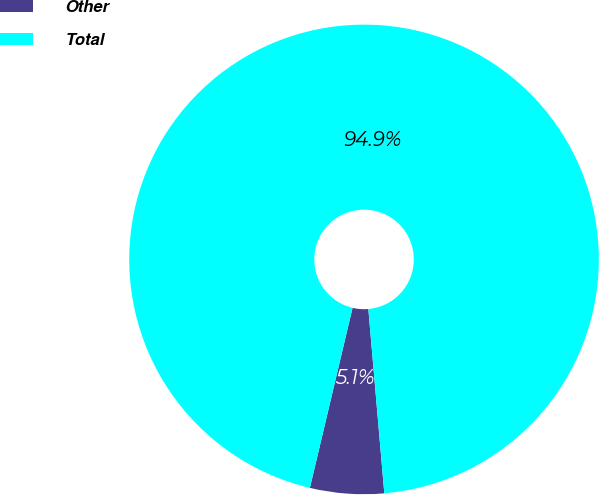<chart> <loc_0><loc_0><loc_500><loc_500><pie_chart><fcel>Other<fcel>Total<nl><fcel>5.08%<fcel>94.92%<nl></chart> 